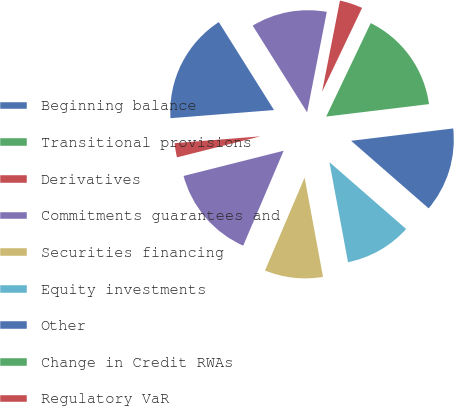<chart> <loc_0><loc_0><loc_500><loc_500><pie_chart><fcel>Beginning balance<fcel>Transitional provisions<fcel>Derivatives<fcel>Commitments guarantees and<fcel>Securities financing<fcel>Equity investments<fcel>Other<fcel>Change in Credit RWAs<fcel>Regulatory VaR<fcel>Stressed VaR<nl><fcel>17.33%<fcel>0.01%<fcel>2.67%<fcel>14.66%<fcel>9.33%<fcel>10.67%<fcel>13.33%<fcel>16.0%<fcel>4.0%<fcel>12.0%<nl></chart> 